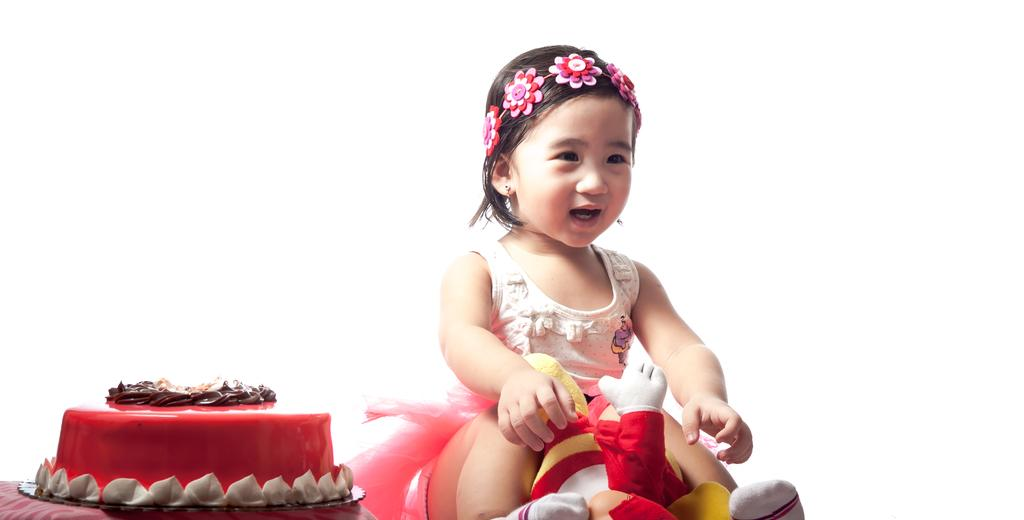What is the main subject of the image? There is a baby in the image. What other objects can be seen in the image? There is a colorful toy and a cake in the image. Can you describe the cake in the image? The cake has red, brown, and white colors. What is the color of the background in the image? The background of the image is white. What type of coat is the baby wearing in the image? There is no coat visible in the image; the baby is not wearing any clothing. 